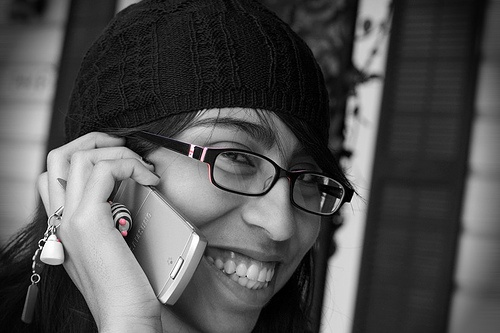Describe the objects in this image and their specific colors. I can see people in black, darkgray, gray, and lightgray tones and cell phone in black, lightgray, darkgray, and gray tones in this image. 